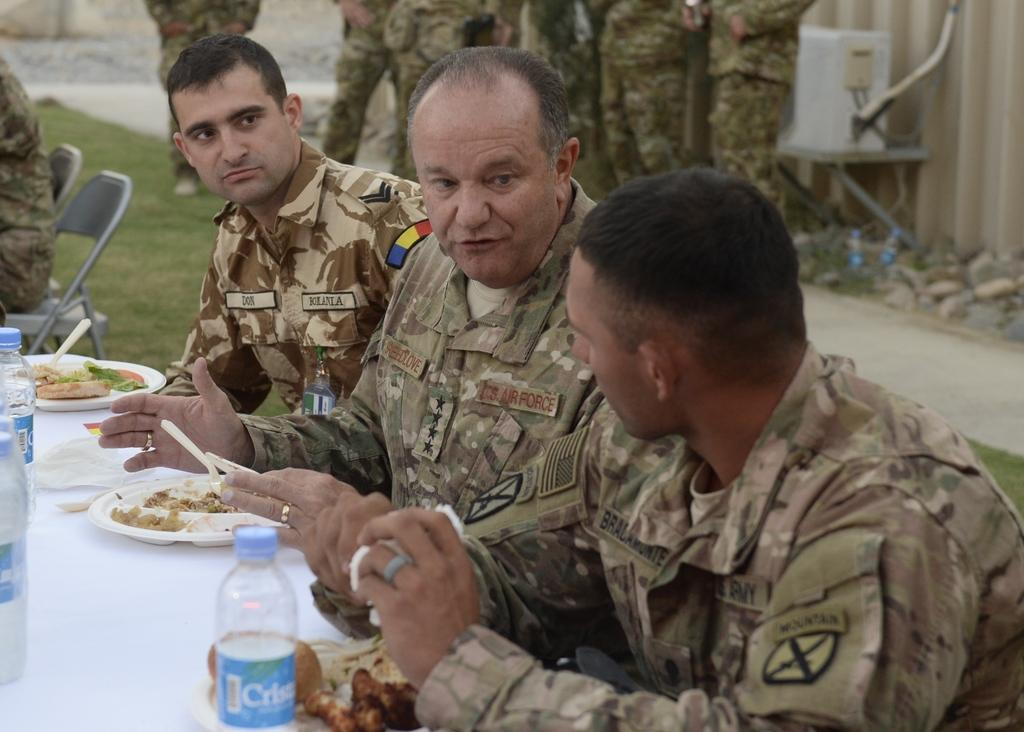How many people are seated around the table in the image? There are three persons sitting on chairs around a table. What can be seen on the table besides the chairs? There are food items on the table. What is happening in the background of the image? In the background, there is a group of persons standing. What type of jellyfish can be seen swimming in the background of the image? There are no jellyfish present in the image; it features a group of persons standing in the background. 